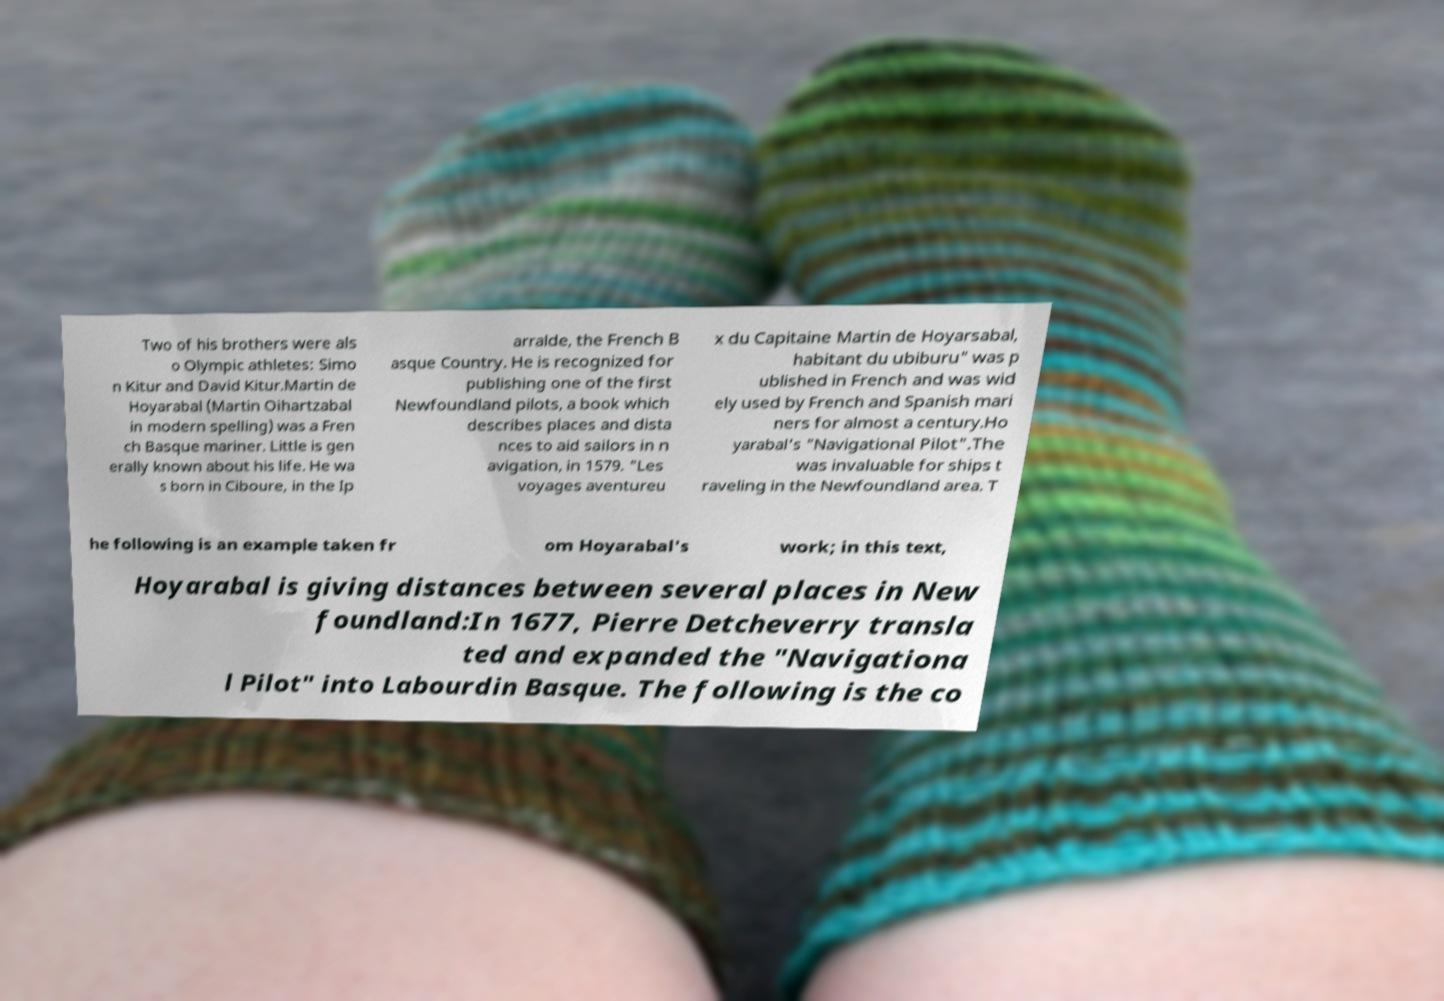I need the written content from this picture converted into text. Can you do that? Two of his brothers were als o Olympic athletes: Simo n Kitur and David Kitur.Martin de Hoyarabal (Martin Oihartzabal in modern spelling) was a Fren ch Basque mariner. Little is gen erally known about his life. He wa s born in Ciboure, in the Ip arralde, the French B asque Country. He is recognized for publishing one of the first Newfoundland pilots, a book which describes places and dista nces to aid sailors in n avigation, in 1579. "Les voyages aventureu x du Capitaine Martin de Hoyarsabal, habitant du ubiburu" was p ublished in French and was wid ely used by French and Spanish mari ners for almost a century.Ho yarabal's "Navigational Pilot".The was invaluable for ships t raveling in the Newfoundland area. T he following is an example taken fr om Hoyarabal's work; in this text, Hoyarabal is giving distances between several places in New foundland:In 1677, Pierre Detcheverry transla ted and expanded the "Navigationa l Pilot" into Labourdin Basque. The following is the co 